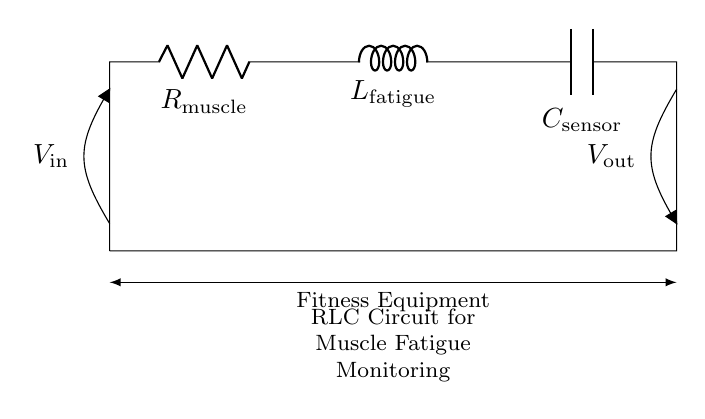What is the resistance in the circuit? The resistance is represented by `R_m`, which stands for `R_muscle`, indicating the resistance related to the muscle in the circuit.
Answer: R_muscle What component represents muscle fatigue? The component that represents muscle fatigue is the inductor, denoted as `L_f`, which stands for `L_fatigue`, indicating its role in the circuit related to fatigue monitoring.
Answer: L_fatigue What is the purpose of the capacitor in this circuit? The capacitor, denoted as `C_s` for `C_sensor`, is used to store electrical energy and can help in filtering or smoothing signals, which is important for accurate monitoring.
Answer: C_sensor What type of circuit is illustrated? The circuit illustrated is an RLC circuit, which consists of a resistor, inductor, and capacitor, utilized for monitoring muscle fatigue in fitness equipment.
Answer: RLC circuit How many components are in this circuit? The circuit contains three primary components: a resistor, an inductor, and a capacitor.
Answer: Three What are the voltage inputs and outputs of the circuit? The voltage input is designated as `V_in`, and the output is labeled `V_out`, indicating the potential difference at the terminals before and after the circuit's operation.
Answer: V_in and V_out 